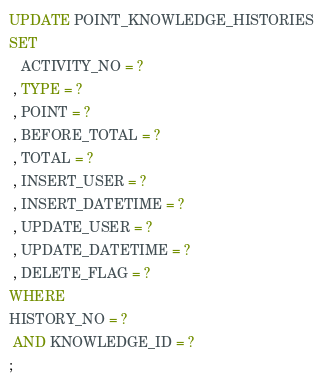Convert code to text. <code><loc_0><loc_0><loc_500><loc_500><_SQL_>UPDATE POINT_KNOWLEDGE_HISTORIES
SET 
   ACTIVITY_NO = ?
 , TYPE = ?
 , POINT = ?
 , BEFORE_TOTAL = ?
 , TOTAL = ?
 , INSERT_USER = ?
 , INSERT_DATETIME = ?
 , UPDATE_USER = ?
 , UPDATE_DATETIME = ?
 , DELETE_FLAG = ?
WHERE 
HISTORY_NO = ?
 AND KNOWLEDGE_ID = ?
;
</code> 